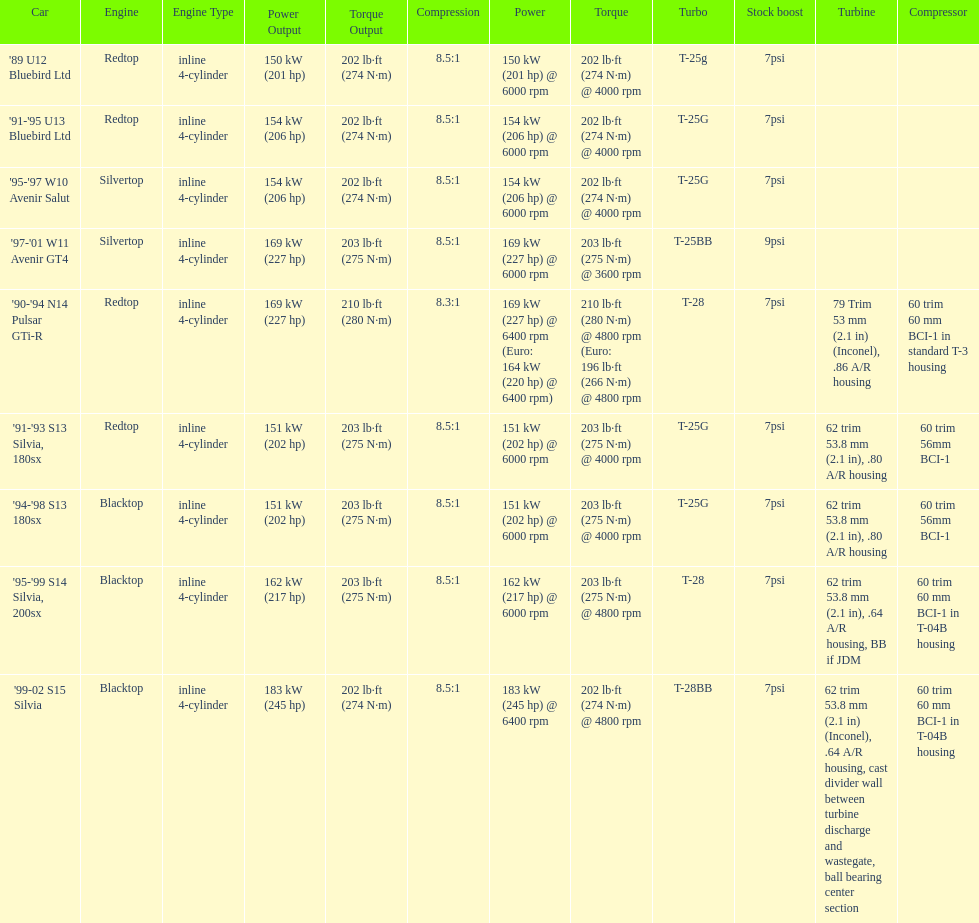Which engines were used after 1999? Silvertop, Blacktop. Parse the table in full. {'header': ['Car', 'Engine', 'Engine Type', 'Power Output', 'Torque Output', 'Compression', 'Power', 'Torque', 'Turbo', 'Stock boost', 'Turbine', 'Compressor'], 'rows': [["'89 U12 Bluebird Ltd", 'Redtop', 'inline 4-cylinder', '150 kW (201 hp)', '202 lb·ft (274 N·m)', '8.5:1', '150\xa0kW (201\xa0hp) @ 6000 rpm', '202\xa0lb·ft (274\xa0N·m) @ 4000 rpm', 'T-25g', '7psi', '', ''], ["'91-'95 U13 Bluebird Ltd", 'Redtop', 'inline 4-cylinder', '154 kW (206 hp)', '202 lb·ft (274 N·m)', '8.5:1', '154\xa0kW (206\xa0hp) @ 6000 rpm', '202\xa0lb·ft (274\xa0N·m) @ 4000 rpm', 'T-25G', '7psi', '', ''], ["'95-'97 W10 Avenir Salut", 'Silvertop', 'inline 4-cylinder', '154 kW (206 hp)', '202 lb·ft (274 N·m)', '8.5:1', '154\xa0kW (206\xa0hp) @ 6000 rpm', '202\xa0lb·ft (274\xa0N·m) @ 4000 rpm', 'T-25G', '7psi', '', ''], ["'97-'01 W11 Avenir GT4", 'Silvertop', 'inline 4-cylinder', '169 kW (227 hp)', '203 lb·ft (275 N·m)', '8.5:1', '169\xa0kW (227\xa0hp) @ 6000 rpm', '203\xa0lb·ft (275\xa0N·m) @ 3600 rpm', 'T-25BB', '9psi', '', ''], ["'90-'94 N14 Pulsar GTi-R", 'Redtop', 'inline 4-cylinder', '169 kW (227 hp)', '210 lb·ft (280 N·m)', '8.3:1', '169\xa0kW (227\xa0hp) @ 6400 rpm (Euro: 164\xa0kW (220\xa0hp) @ 6400 rpm)', '210\xa0lb·ft (280\xa0N·m) @ 4800 rpm (Euro: 196\xa0lb·ft (266\xa0N·m) @ 4800 rpm', 'T-28', '7psi', '79 Trim 53\xa0mm (2.1\xa0in) (Inconel), .86 A/R housing', '60 trim 60\xa0mm BCI-1 in standard T-3 housing'], ["'91-'93 S13 Silvia, 180sx", 'Redtop', 'inline 4-cylinder', '151 kW (202 hp)', '203 lb·ft (275 N·m)', '8.5:1', '151\xa0kW (202\xa0hp) @ 6000 rpm', '203\xa0lb·ft (275\xa0N·m) @ 4000 rpm', 'T-25G', '7psi', '62 trim 53.8\xa0mm (2.1\xa0in), .80 A/R housing', '60 trim 56mm BCI-1'], ["'94-'98 S13 180sx", 'Blacktop', 'inline 4-cylinder', '151 kW (202 hp)', '203 lb·ft (275 N·m)', '8.5:1', '151\xa0kW (202\xa0hp) @ 6000 rpm', '203\xa0lb·ft (275\xa0N·m) @ 4000 rpm', 'T-25G', '7psi', '62 trim 53.8\xa0mm (2.1\xa0in), .80 A/R housing', '60 trim 56mm BCI-1'], ["'95-'99 S14 Silvia, 200sx", 'Blacktop', 'inline 4-cylinder', '162 kW (217 hp)', '203 lb·ft (275 N·m)', '8.5:1', '162\xa0kW (217\xa0hp) @ 6000 rpm', '203\xa0lb·ft (275\xa0N·m) @ 4800 rpm', 'T-28', '7psi', '62 trim 53.8\xa0mm (2.1\xa0in), .64 A/R housing, BB if JDM', '60 trim 60\xa0mm BCI-1 in T-04B housing'], ["'99-02 S15 Silvia", 'Blacktop', 'inline 4-cylinder', '183 kW (245 hp)', '202 lb·ft (274 N·m)', '8.5:1', '183\xa0kW (245\xa0hp) @ 6400 rpm', '202\xa0lb·ft (274\xa0N·m) @ 4800 rpm', 'T-28BB', '7psi', '62 trim 53.8\xa0mm (2.1\xa0in) (Inconel), .64 A/R housing, cast divider wall between turbine discharge and wastegate, ball bearing center section', '60 trim 60\xa0mm BCI-1 in T-04B housing']]} 